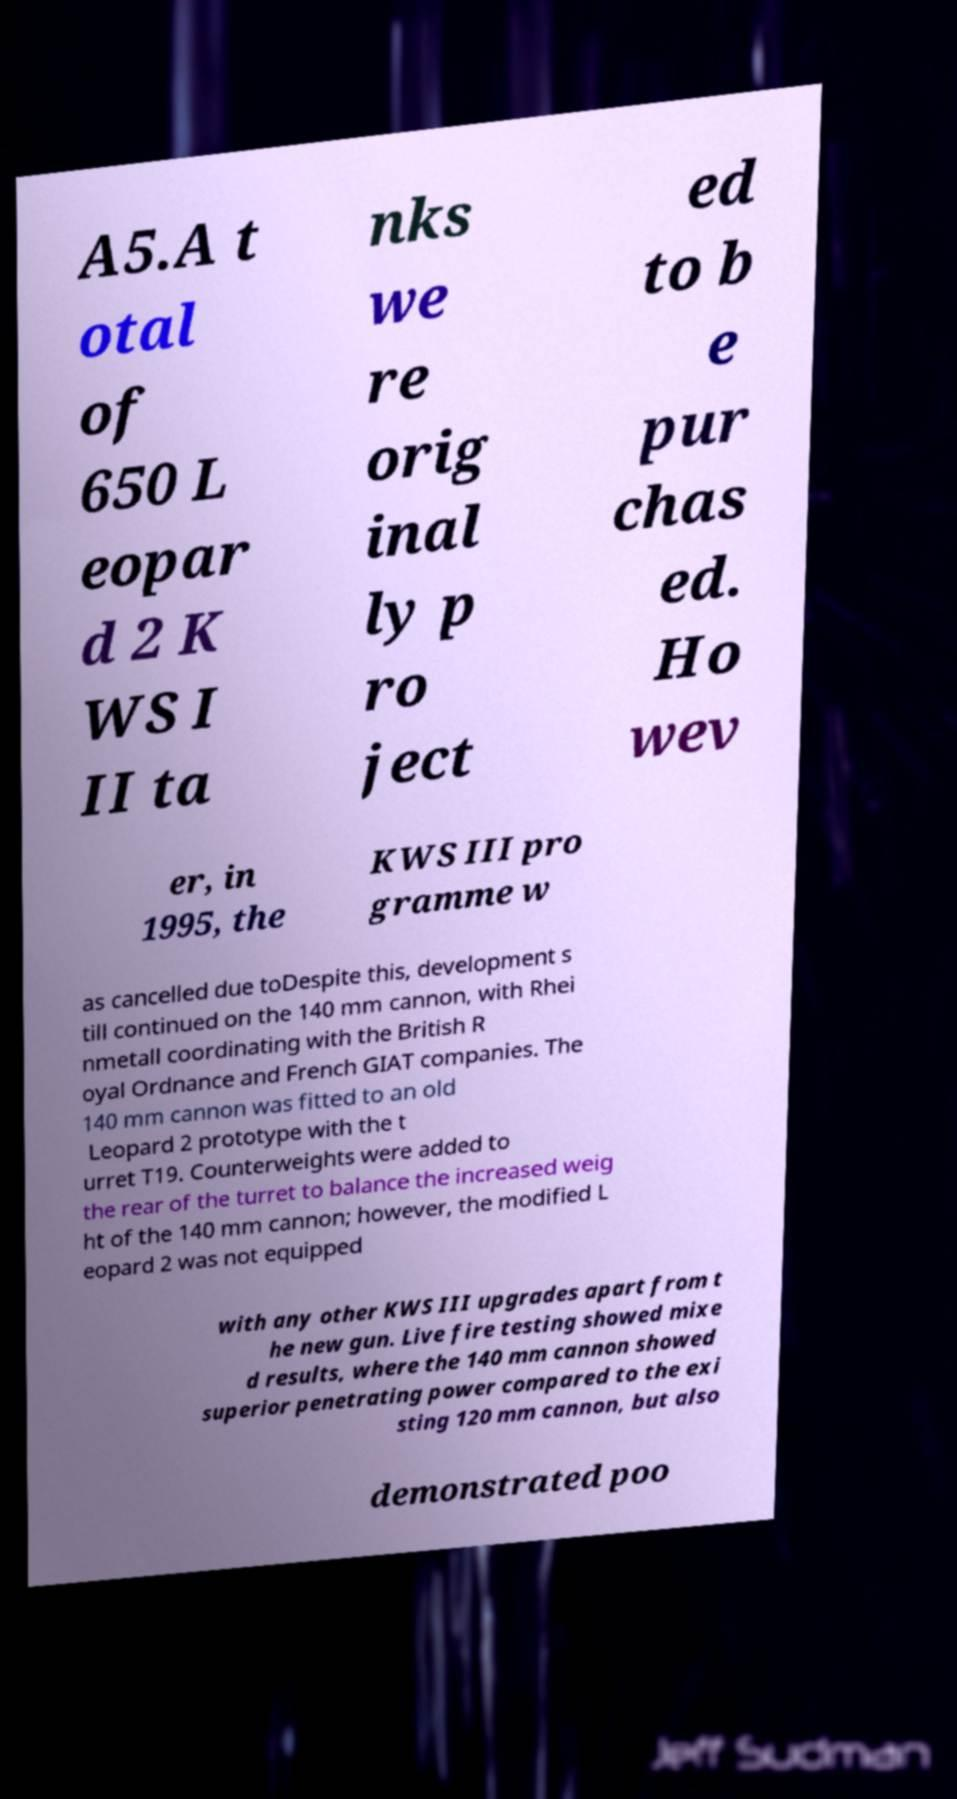There's text embedded in this image that I need extracted. Can you transcribe it verbatim? A5.A t otal of 650 L eopar d 2 K WS I II ta nks we re orig inal ly p ro ject ed to b e pur chas ed. Ho wev er, in 1995, the KWS III pro gramme w as cancelled due toDespite this, development s till continued on the 140 mm cannon, with Rhei nmetall coordinating with the British R oyal Ordnance and French GIAT companies. The 140 mm cannon was fitted to an old Leopard 2 prototype with the t urret T19. Counterweights were added to the rear of the turret to balance the increased weig ht of the 140 mm cannon; however, the modified L eopard 2 was not equipped with any other KWS III upgrades apart from t he new gun. Live fire testing showed mixe d results, where the 140 mm cannon showed superior penetrating power compared to the exi sting 120 mm cannon, but also demonstrated poo 